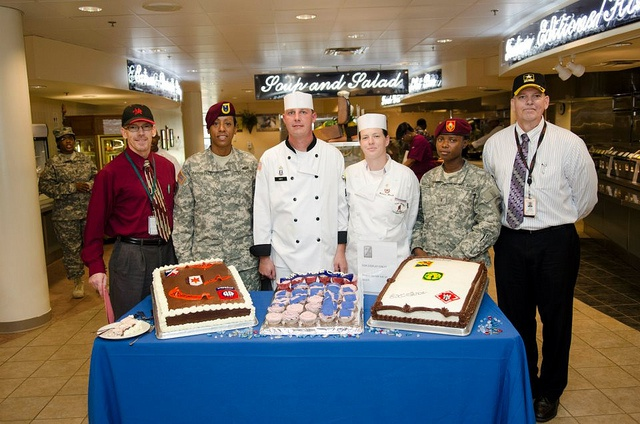Describe the objects in this image and their specific colors. I can see dining table in gray, blue, ivory, navy, and maroon tones, people in gray, black, lightgray, and darkgray tones, people in gray, lightgray, salmon, black, and darkgray tones, people in gray, black, maroon, and brown tones, and people in gray, darkgray, and black tones in this image. 